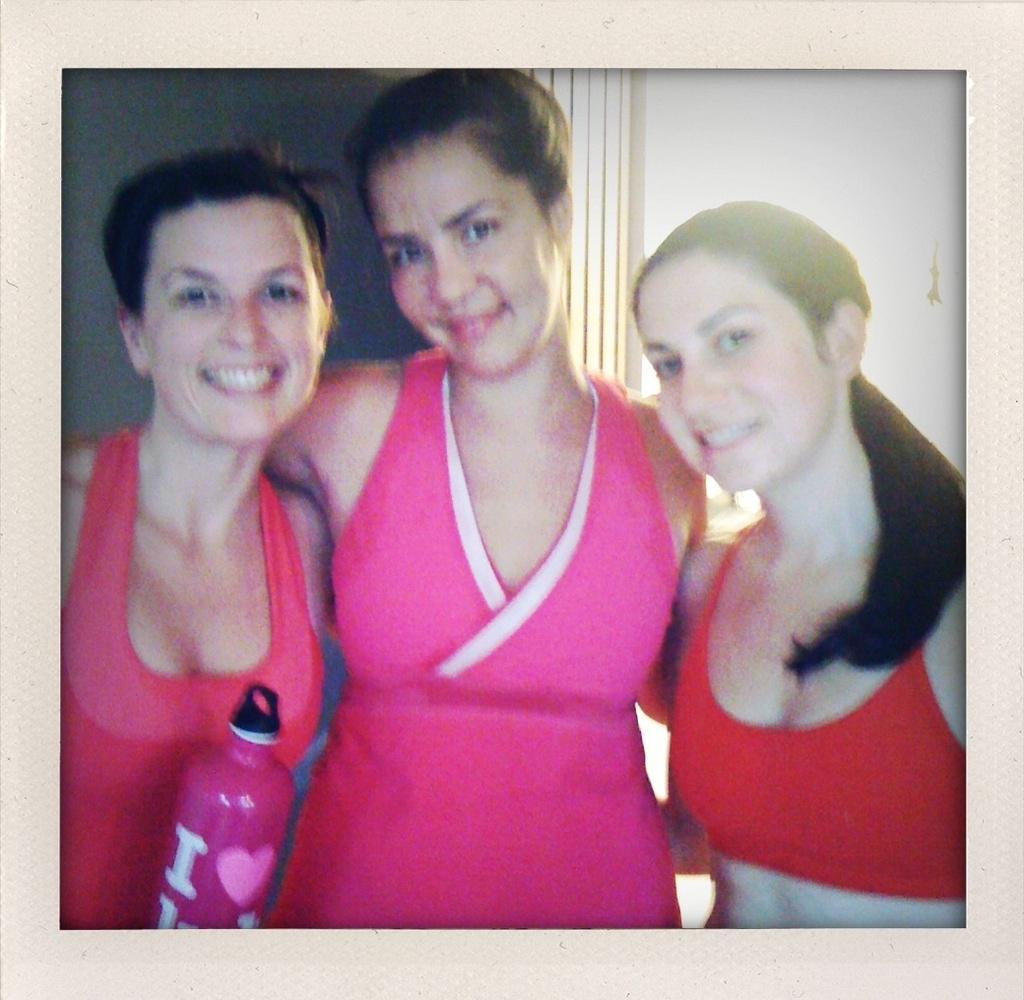In one or two sentences, can you explain what this image depicts? In this image we can see a photo frame. There are three ladies. One lady is holding a bottle. In the background there is wall. 